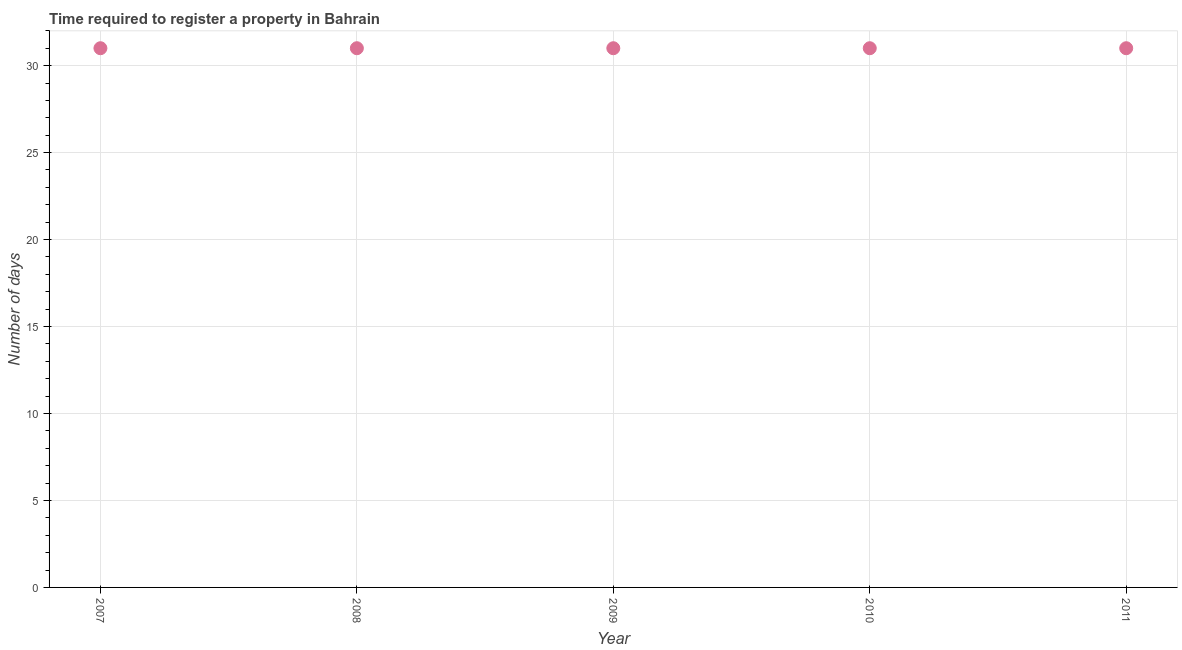What is the number of days required to register property in 2010?
Offer a very short reply. 31. Across all years, what is the maximum number of days required to register property?
Provide a succinct answer. 31. Across all years, what is the minimum number of days required to register property?
Keep it short and to the point. 31. In which year was the number of days required to register property minimum?
Your answer should be very brief. 2007. What is the sum of the number of days required to register property?
Provide a succinct answer. 155. What is the difference between the number of days required to register property in 2008 and 2011?
Offer a terse response. 0. What is the average number of days required to register property per year?
Offer a very short reply. 31. What is the median number of days required to register property?
Your answer should be compact. 31. In how many years, is the number of days required to register property greater than 20 days?
Keep it short and to the point. 5. What is the ratio of the number of days required to register property in 2007 to that in 2011?
Keep it short and to the point. 1. Is the number of days required to register property in 2007 less than that in 2010?
Your answer should be very brief. No. Does the number of days required to register property monotonically increase over the years?
Provide a succinct answer. No. How many dotlines are there?
Your answer should be very brief. 1. How many years are there in the graph?
Your answer should be very brief. 5. What is the difference between two consecutive major ticks on the Y-axis?
Your response must be concise. 5. Does the graph contain any zero values?
Give a very brief answer. No. What is the title of the graph?
Your answer should be compact. Time required to register a property in Bahrain. What is the label or title of the Y-axis?
Provide a short and direct response. Number of days. What is the Number of days in 2008?
Offer a terse response. 31. What is the Number of days in 2009?
Make the answer very short. 31. What is the Number of days in 2010?
Your answer should be compact. 31. What is the difference between the Number of days in 2007 and 2009?
Keep it short and to the point. 0. What is the difference between the Number of days in 2009 and 2011?
Ensure brevity in your answer.  0. What is the difference between the Number of days in 2010 and 2011?
Provide a succinct answer. 0. What is the ratio of the Number of days in 2007 to that in 2008?
Your answer should be very brief. 1. What is the ratio of the Number of days in 2007 to that in 2009?
Give a very brief answer. 1. What is the ratio of the Number of days in 2007 to that in 2010?
Offer a very short reply. 1. 